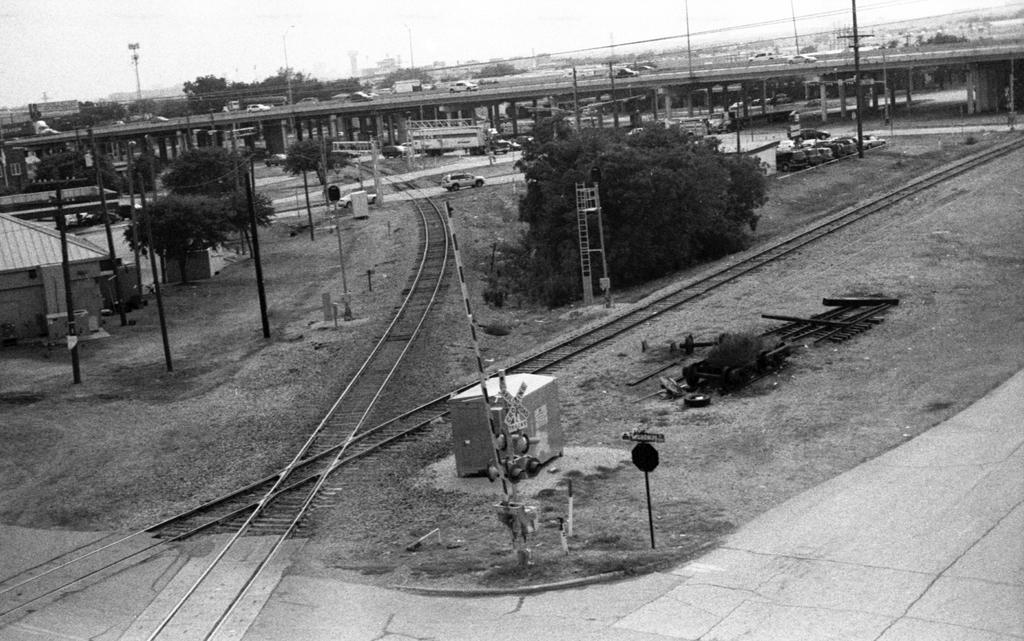What type of transportation infrastructure is present in the image? There is a railway track in the image. What other structures can be seen in the image? There are poles, a bridge, and cable wires visible in the image. What type of vegetation is present in the image? Trees are present in the image. What is visible at the top of the image? The sky is visible at the top of the image. What else can be seen in the image? Vehicles are visible in the image. What is the tendency of the battle in the image? There is no battle present in the image, so it is not possible to determine any tendencies. 